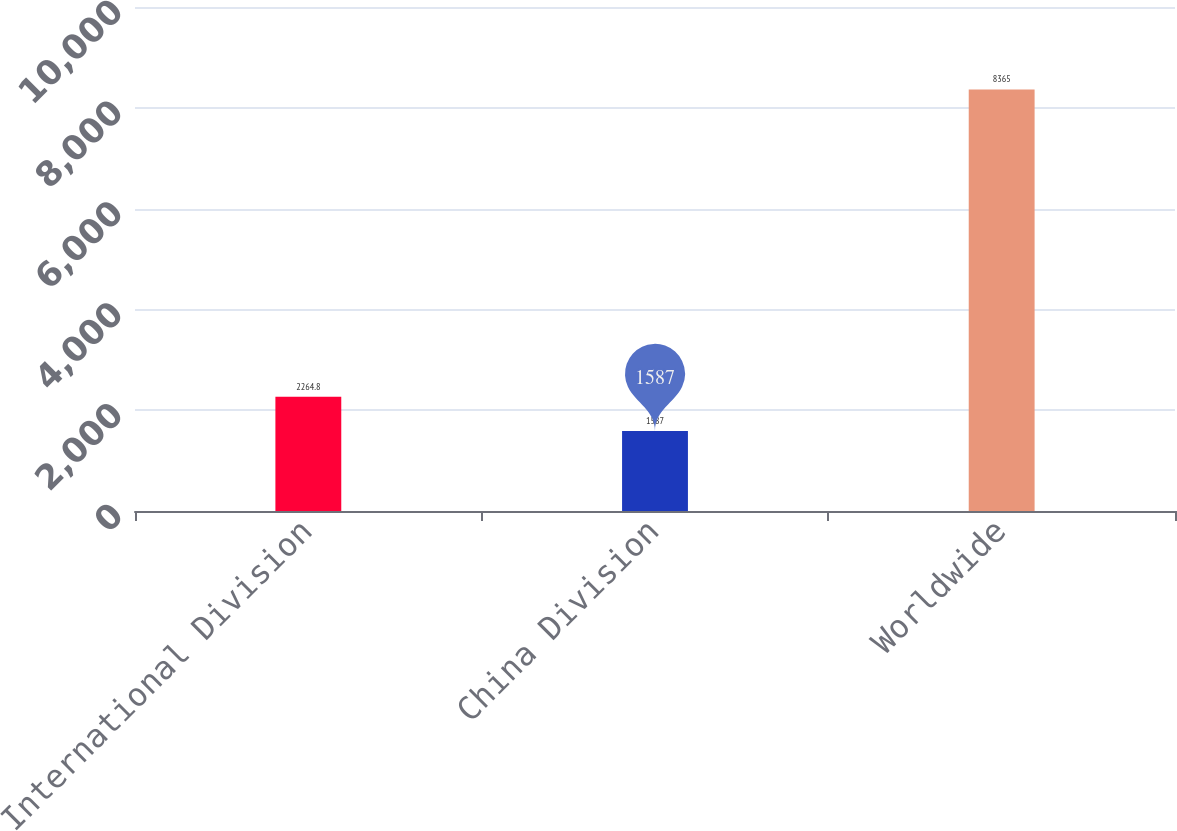Convert chart to OTSL. <chart><loc_0><loc_0><loc_500><loc_500><bar_chart><fcel>International Division<fcel>China Division<fcel>Worldwide<nl><fcel>2264.8<fcel>1587<fcel>8365<nl></chart> 